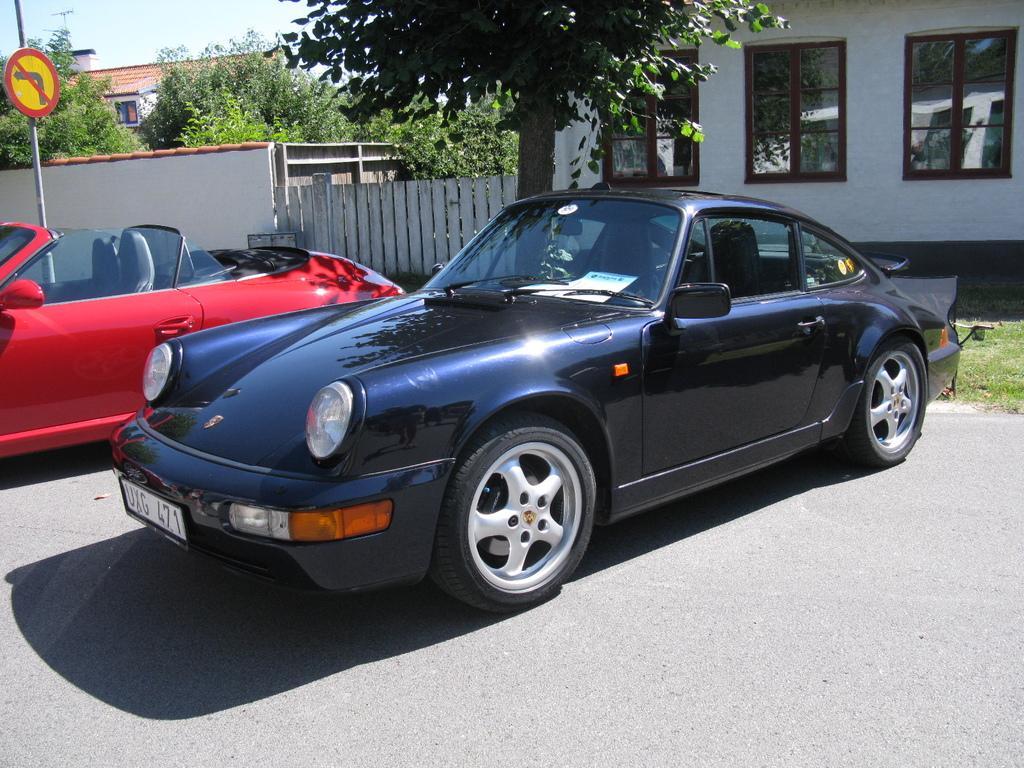Describe this image in one or two sentences. In this picture we can see cars on the ground, pole, signboard, trees, buildings with windows, some objects and in the background we can see the sky. 